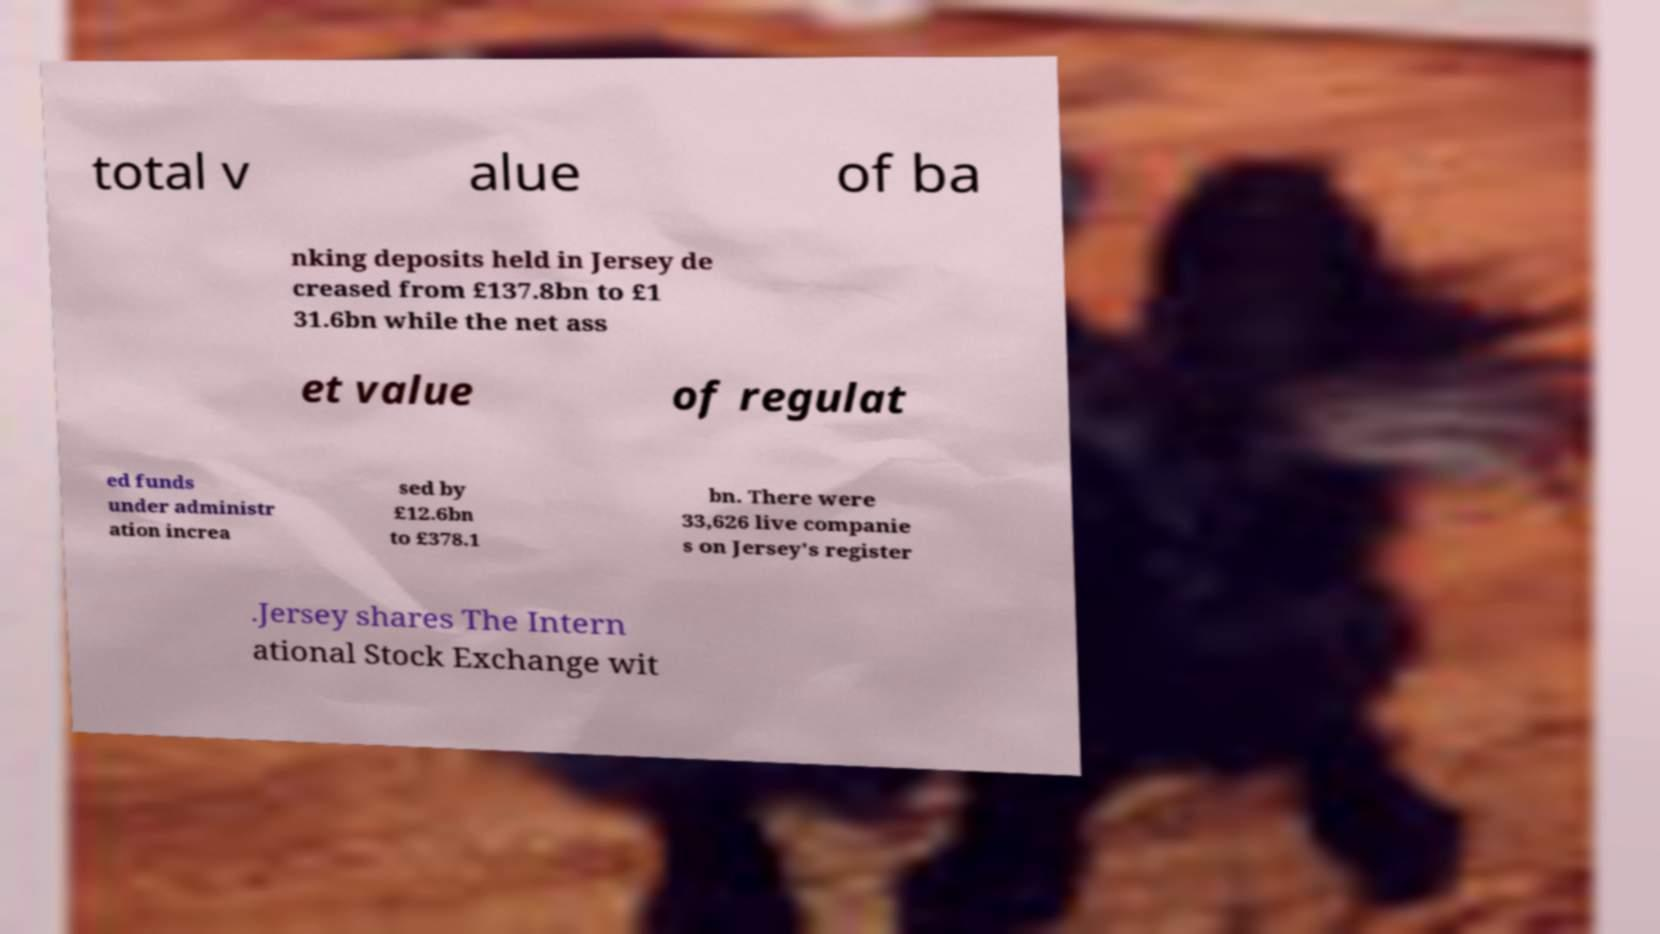I need the written content from this picture converted into text. Can you do that? total v alue of ba nking deposits held in Jersey de creased from £137.8bn to £1 31.6bn while the net ass et value of regulat ed funds under administr ation increa sed by £12.6bn to £378.1 bn. There were 33,626 live companie s on Jersey's register .Jersey shares The Intern ational Stock Exchange wit 